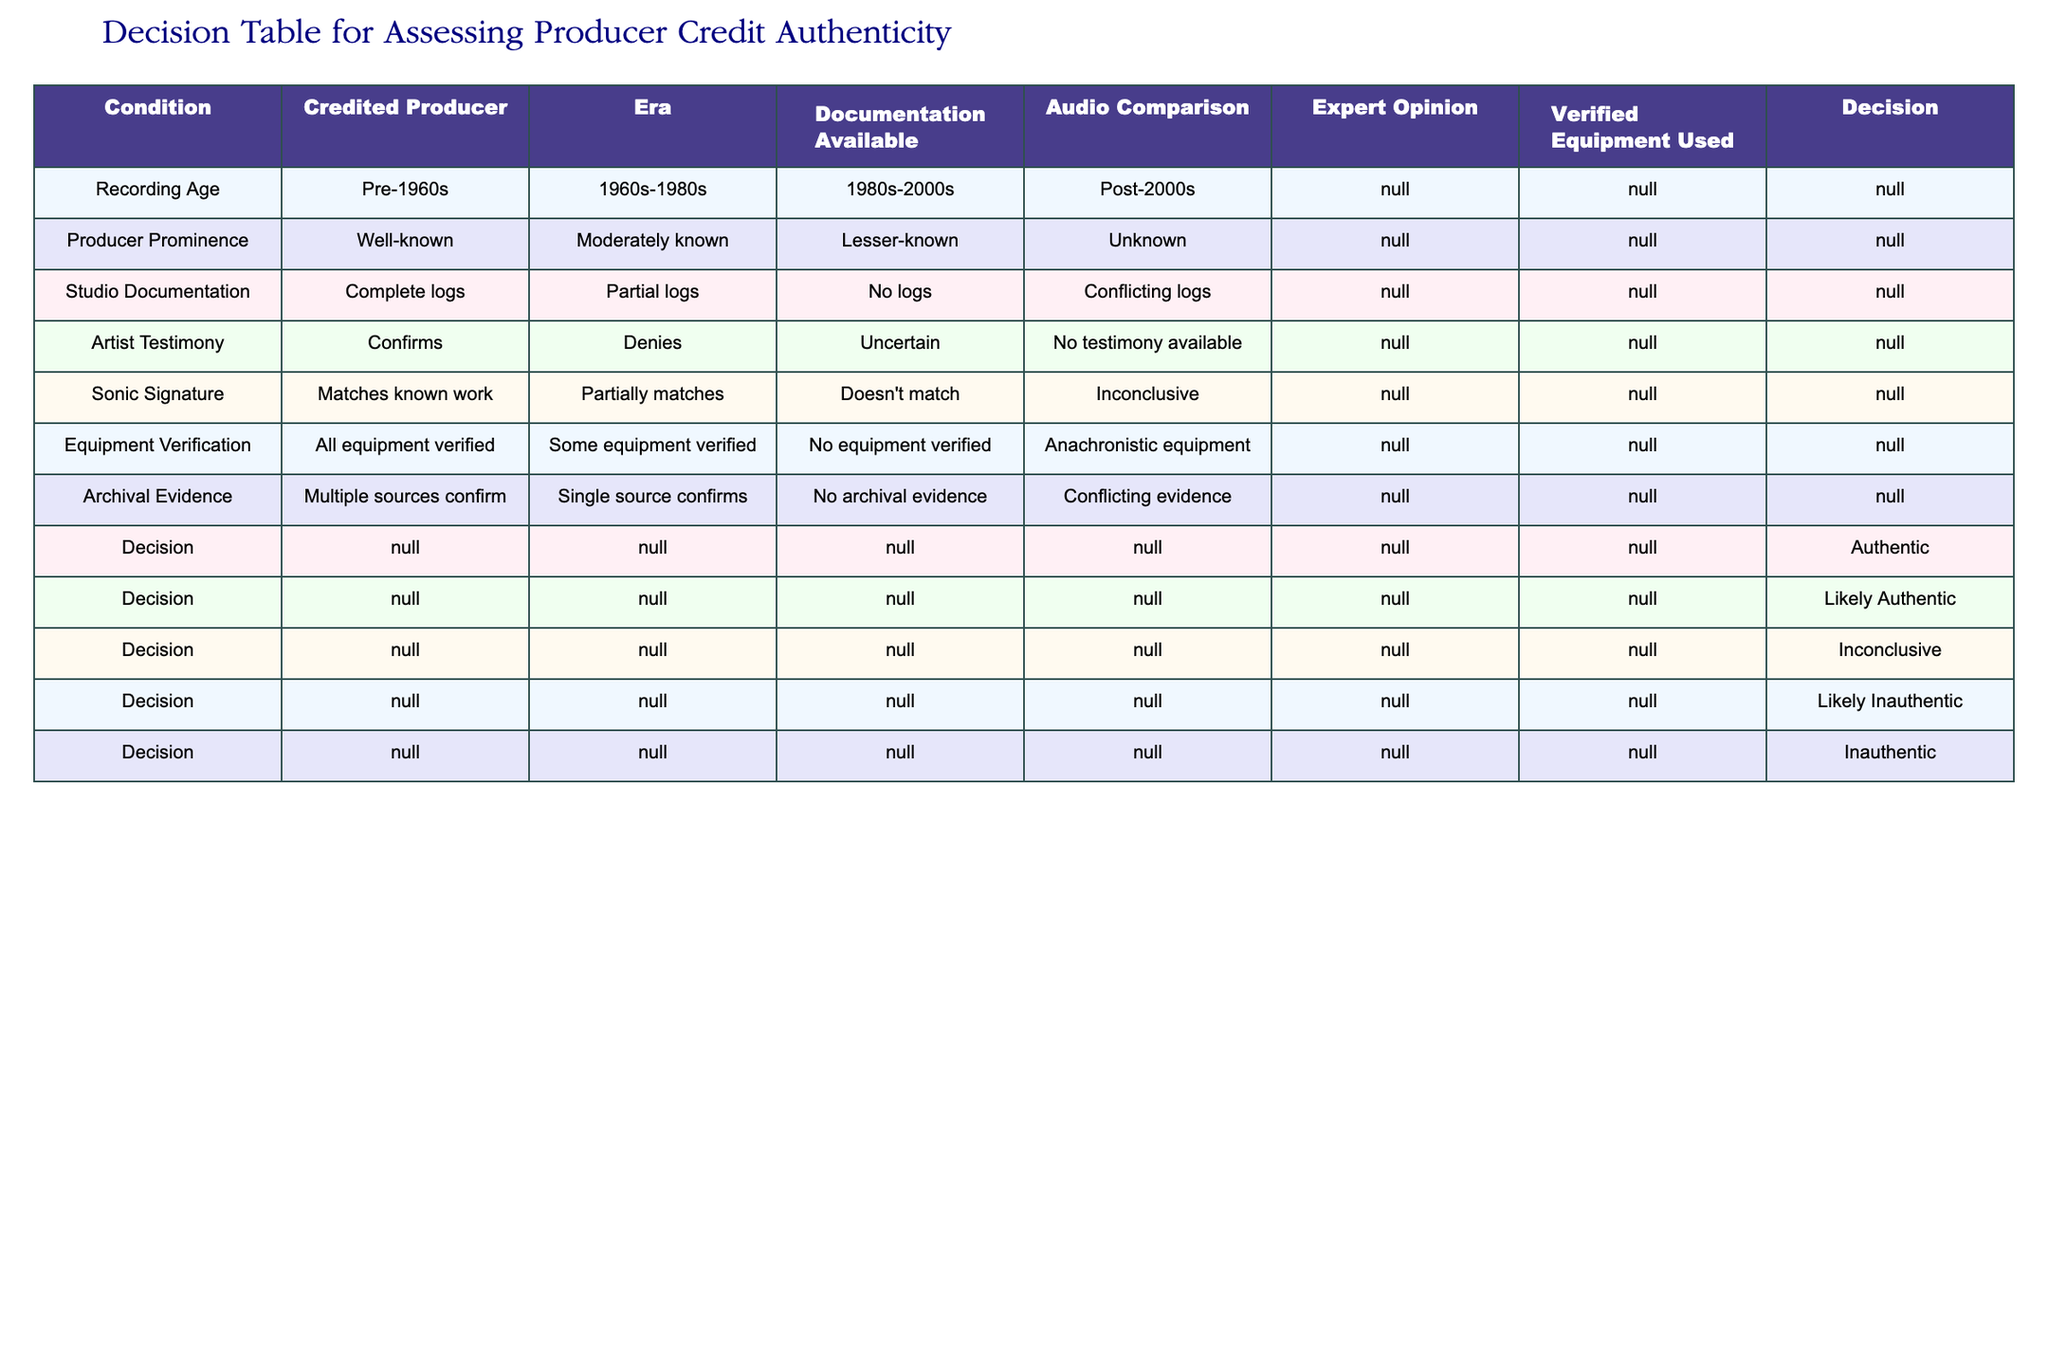What is the decision category for well-known producers with complete logs and confirms from the artist? In the table, "Well-known" producers are found in the "Producer Prominence" section, "Complete logs" under "Studio Documentation," and "Confirms" under "Artist Testimony." All these conditions lead to the decision category of "Authentic."
Answer: Authentic Is the presence of anachronistic equipment a reason for a decision of inauthenticity? Yes, if "Anachronistic equipment" is listed under "Equipment Verification," it results in a decision category of "Inauthentic." This indicates that the equipment used could not have been relevant to the recording era.
Answer: Yes What are the possible decisions for recordings with uncertain artist testimony and conflicting logs? To find this, look under the "Decision" section with the conditions of "Uncertain" testimony and "Conflicting logs" in the table. These lead to a decision of "Likely Inauthentic."
Answer: Likely Inauthentic How many types of sonic signature matching are mentioned in the table? There are three types of sonic signature matching: "Matches known work," "Partially matches," and "Doesn't match." This means that there's a total of three classifications in the table that relate to sonic signature.
Answer: 3 For recordings with lesser-known producers and single source confirmations, what is the decision? Checking the "Lesser-known" section under "Producer Prominence" and "Single source confirms" under "Archival Evidence," this leads to a decision of "Inconclusive." This reflects a lack of substantial evidence backing the claim.
Answer: Inconclusive What dual conditions would yield a decision of "Likely Authentic"? The table identifies that for a "Likely Authentic" decision, there must be conditions such as "Moderately known" producer and "Partial logs" documentation alongside "Confirms" artist testimony. These combined lead to a decision of "Likely Authentic."
Answer: Likely Authentic Does multiple sources confirming archival evidence guarantee authenticity? Not necessarily; while multiple sources confirming archival evidence is favorable, the overall decision also depends on other factors like studio documentation and producer prominence. Thus, it does not guarantee authenticity on its own.
Answer: No In what scenario would an unknown producer result in an inauthentic decision? An unknown producer leads to an "Inauthentic" decision when combined with "No logs" for studio documentation, "Denies" artist testimony, and "No archival evidence." These collectively represent a lack of authentication for the producer's claim.
Answer: Unknown producer & lacking logs and testimony yields Inauthentic 